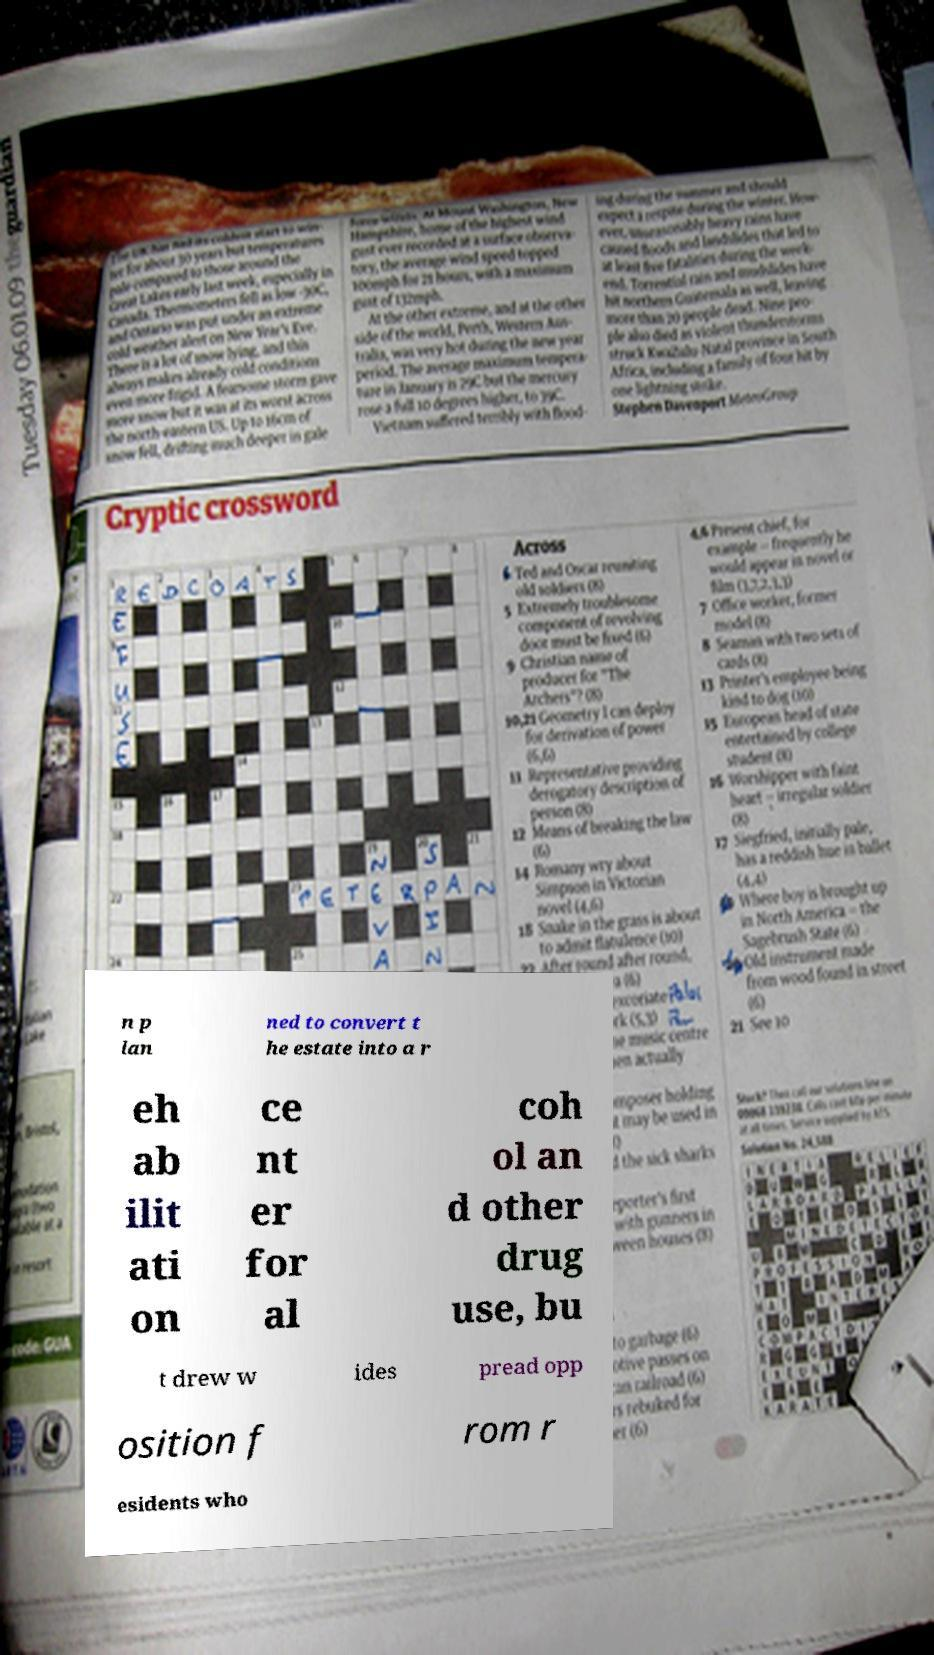Could you assist in decoding the text presented in this image and type it out clearly? n p lan ned to convert t he estate into a r eh ab ilit ati on ce nt er for al coh ol an d other drug use, bu t drew w ides pread opp osition f rom r esidents who 